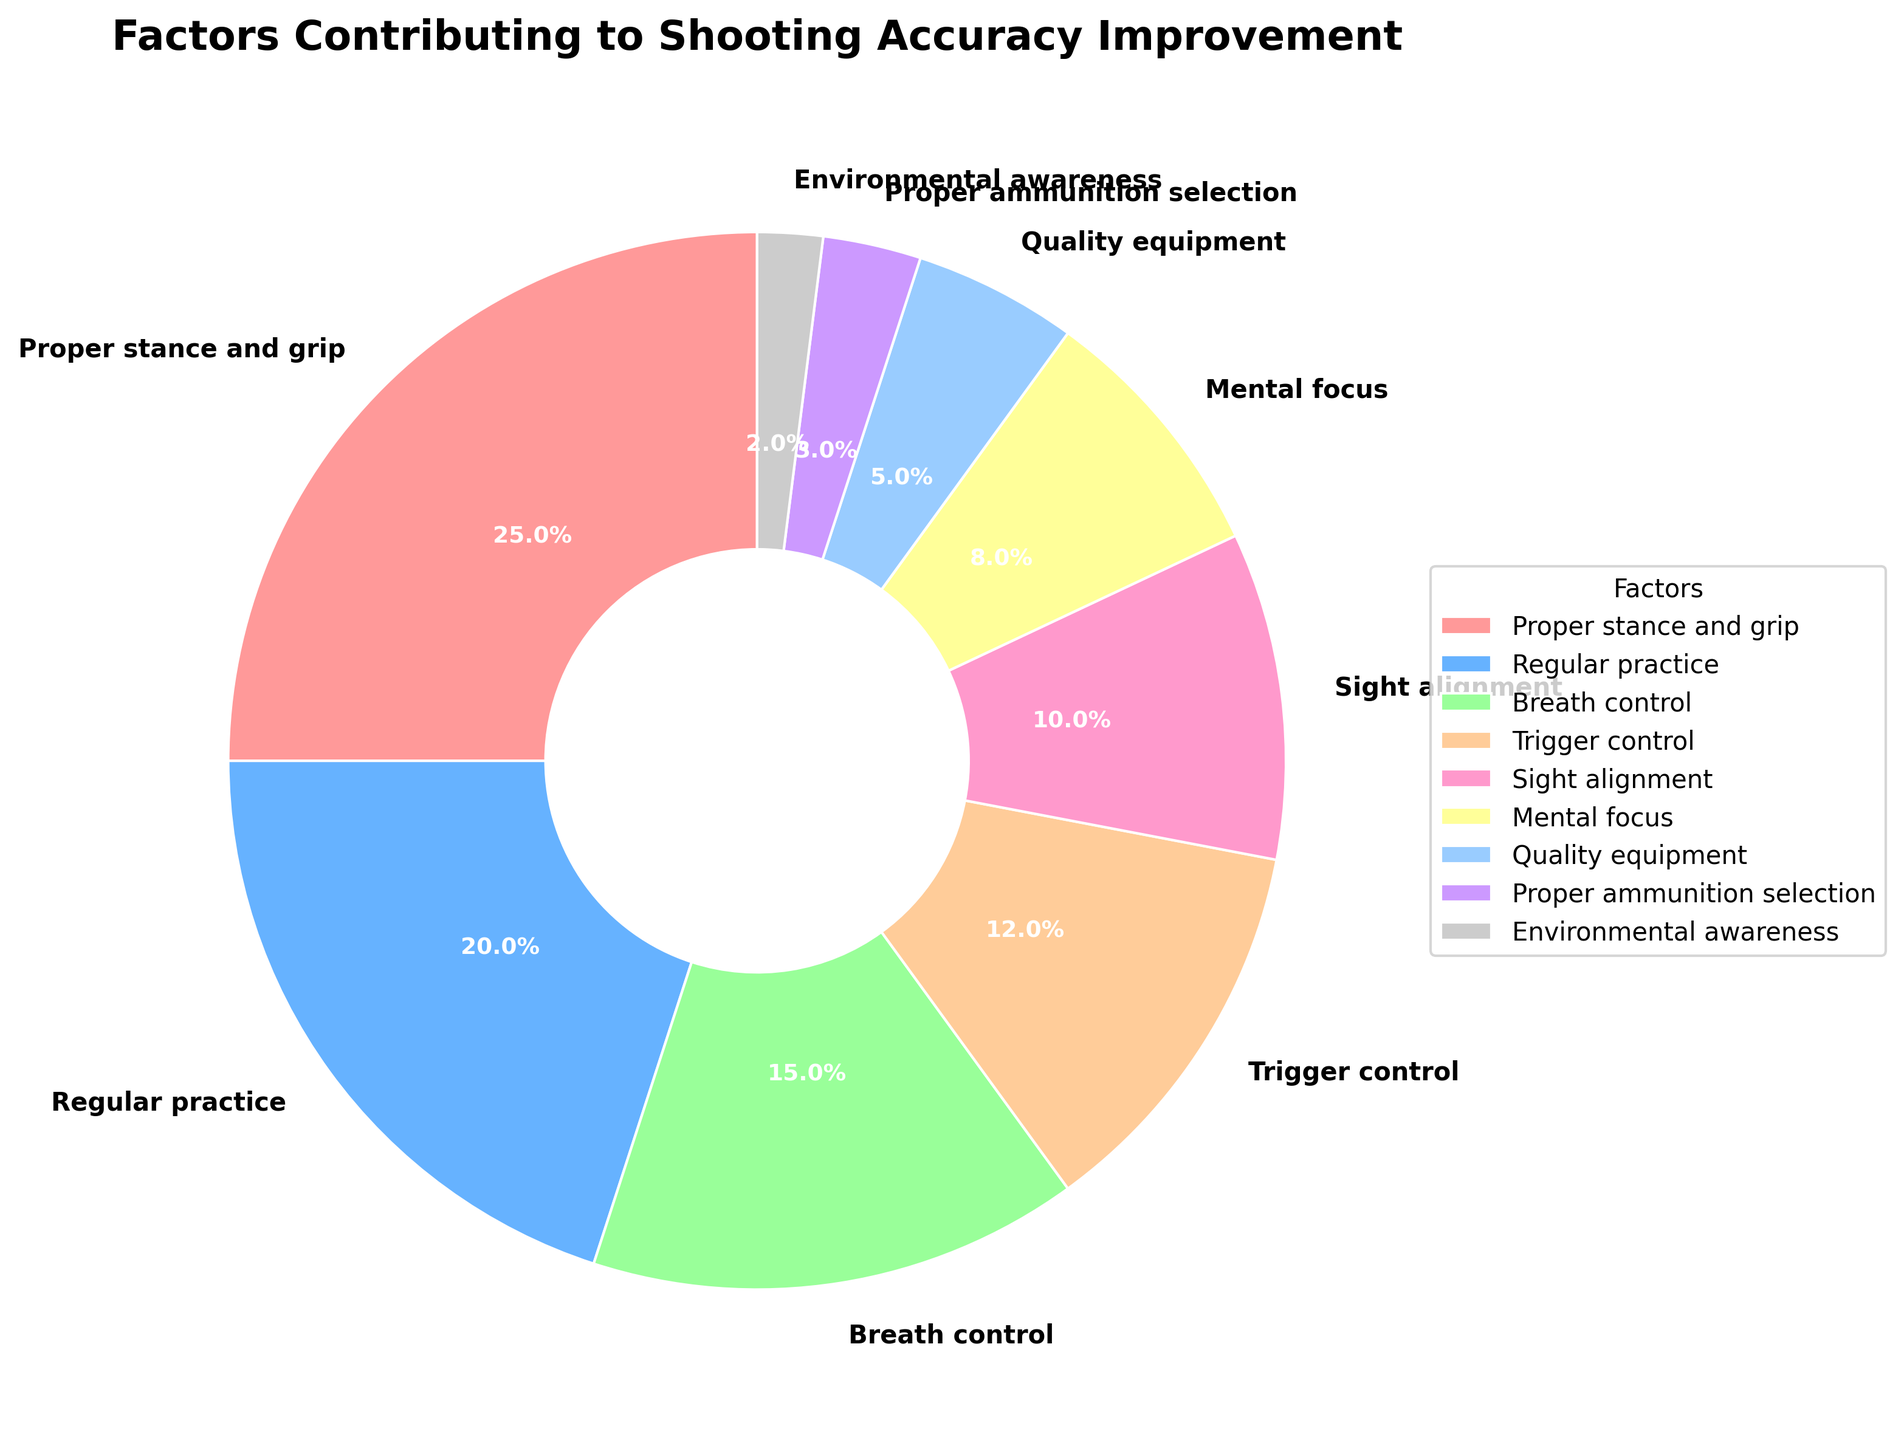Which factor contributes the highest percentage to shooting accuracy improvement? By analyzing the pie chart, the factor that covers the largest segment will have the highest percentage. In this case, "Proper stance and grip" has the largest share.
Answer: Proper stance and grip Which two factors together account for 35% of the contribution? Adding the percentages of factors until reaching 35%, "Proper stance and grip" (25%) + "Breath control" (15%) = 40%; but, "Regular practice" (20%) + "Breath control" (15%) = 35%.
Answer: Regular practice and Breath control Which factors have a contribution of less than 10%? By looking at the segments, the factors that have less than 10% are "Mental focus" (8%), "Quality equipment" (5%), "Proper ammunition selection" (3%), and "Environmental awareness" (2%).
Answer: Mental focus, Quality equipment, Proper ammunition selection, Environmental awareness How much greater is the percentage contribution of "Proper stance and grip" compared to "Trigger control"? Subtract the percentage of "Trigger control" (12%) from "Proper stance and grip" (25%) to find the difference.
Answer: 13% What is the average percentage contribution of factors contributing between 10% and 15%? Identify the relevant factors, namely "Breath control" (15%), "Trigger control" (12%), and "Sight alignment" (10%). Sum these values (15 + 12 + 10 = 37) and then divide by the number of factors (3).
Answer: 12.33% Which segment is represented in pink color? By referring to the color scheme in the pie chart, particularly looking for pink, the segment colored in pink is "Proper stance and grip".
Answer: Proper stance and grip Which factor contributes the least to shooting accuracy improvement? Identify the smallest segment in the pie chart, which will have the lowest percentage contribution. In this case, "Environmental awareness" has the smallest share with 2%.
Answer: Environmental awareness 